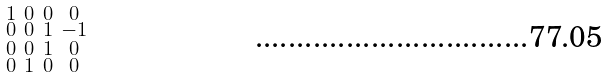<formula> <loc_0><loc_0><loc_500><loc_500>\begin{smallmatrix} 1 & 0 & 0 & 0 \\ 0 & 0 & 1 & - 1 \\ 0 & 0 & 1 & 0 \\ 0 & 1 & 0 & 0 \end{smallmatrix}</formula> 